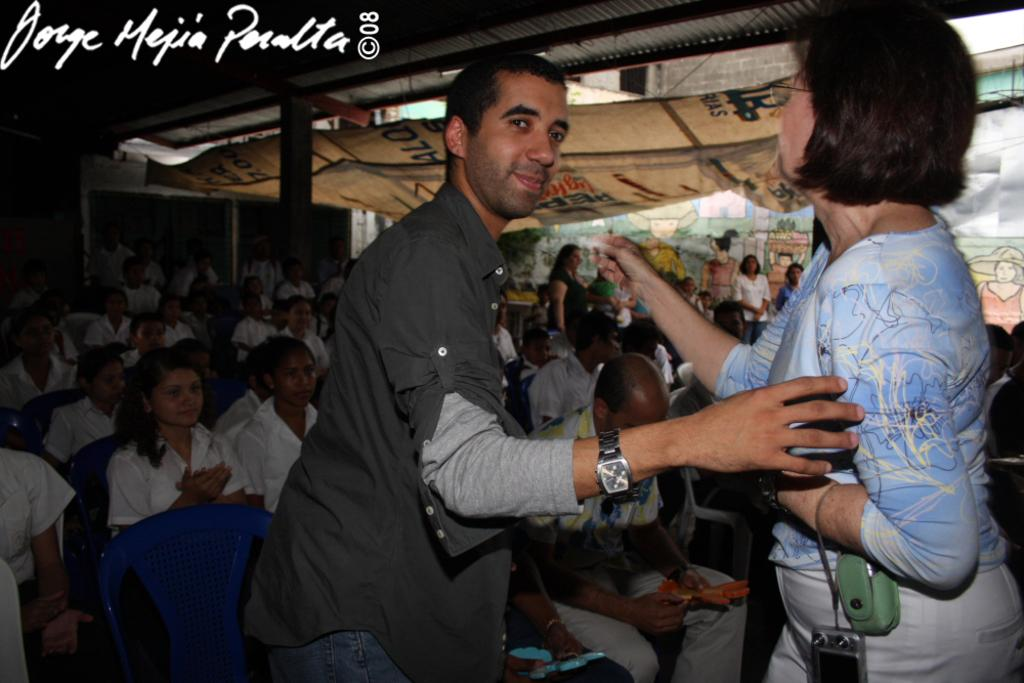Who are the two people standing in the middle of the image? There is a man and a woman standing in the middle of the image. What is happening in the background of the image? There is a group of people sitting in the background of the image. What are the people sitting on in the background? The group of people are sitting on chairs. What can be seen in the top left hand side of the image? There is text visible in the top left hand side of the image. What type of heart can be seen beating in the image? There is no heart visible in the image, beating or otherwise. 